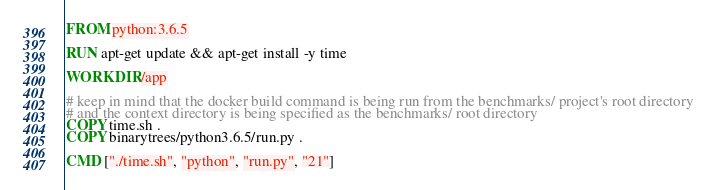<code> <loc_0><loc_0><loc_500><loc_500><_Dockerfile_>FROM python:3.6.5

RUN apt-get update && apt-get install -y time

WORKDIR /app

# keep in mind that the docker build command is being run from the benchmarks/ project's root directory
# and the context directory is being specified as the benchmarks/ root directory
COPY time.sh .
COPY binarytrees/python3.6.5/run.py .

CMD ["./time.sh", "python", "run.py", "21"]</code> 